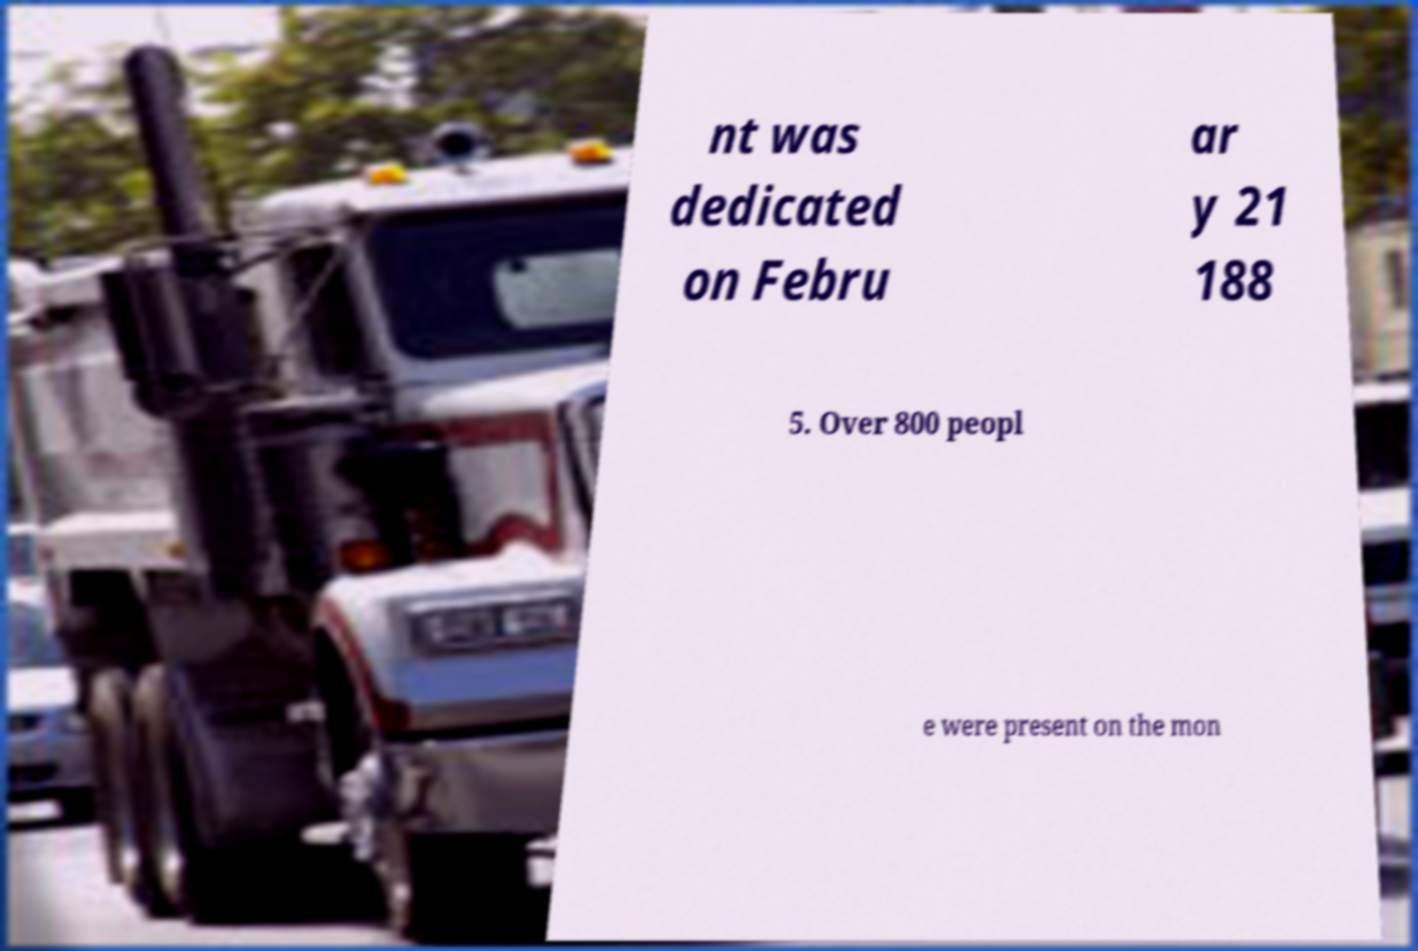Can you accurately transcribe the text from the provided image for me? nt was dedicated on Febru ar y 21 188 5. Over 800 peopl e were present on the mon 